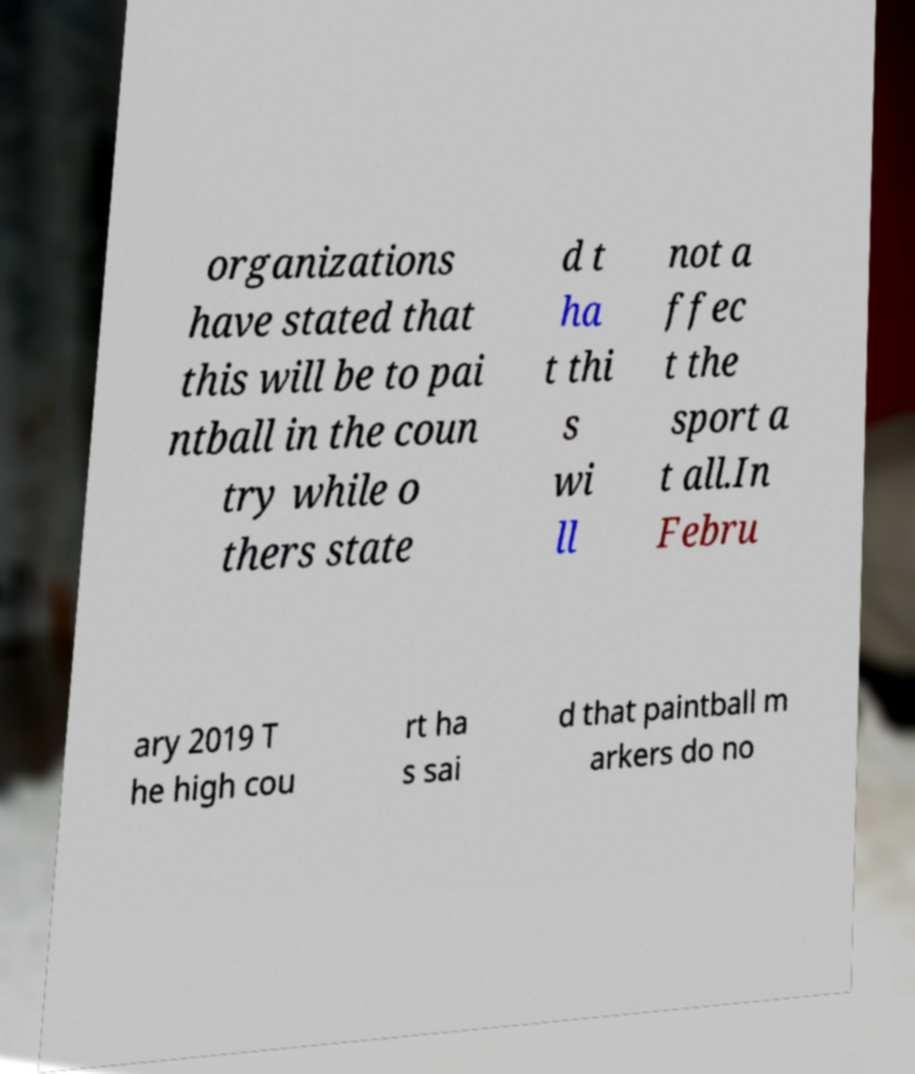Can you accurately transcribe the text from the provided image for me? organizations have stated that this will be to pai ntball in the coun try while o thers state d t ha t thi s wi ll not a ffec t the sport a t all.In Febru ary 2019 T he high cou rt ha s sai d that paintball m arkers do no 